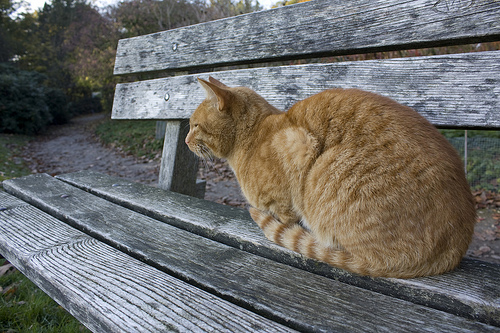Are there any benches in front of the path? Yes, there is a bench in front of the path. 